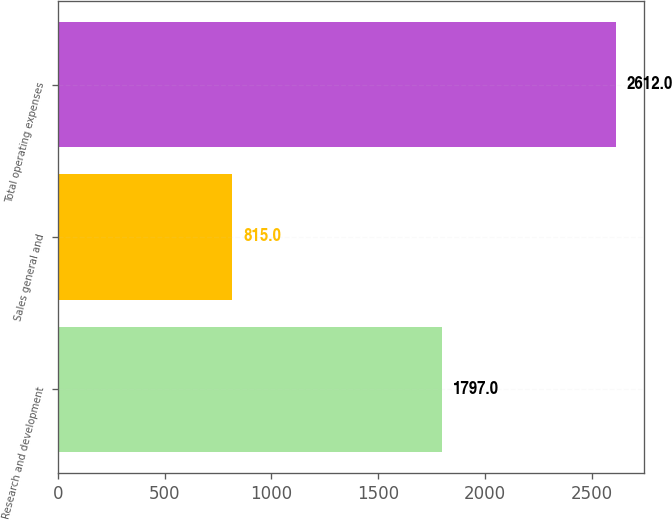Convert chart to OTSL. <chart><loc_0><loc_0><loc_500><loc_500><bar_chart><fcel>Research and development<fcel>Sales general and<fcel>Total operating expenses<nl><fcel>1797<fcel>815<fcel>2612<nl></chart> 